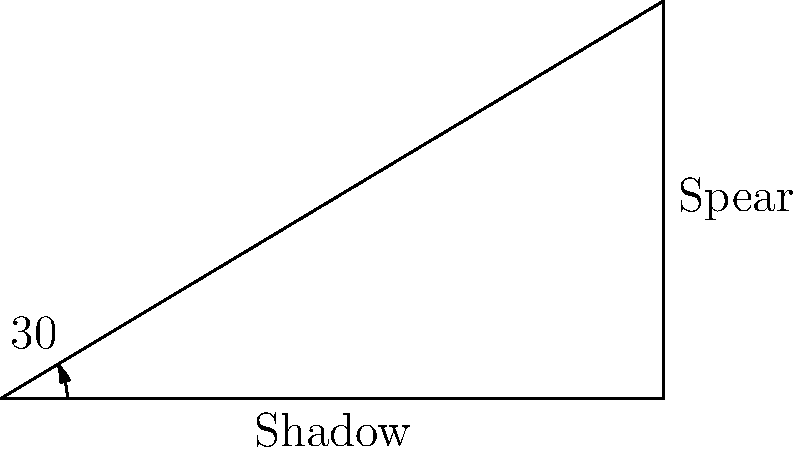An archaeologist discovers an ancient spear casting a shadow on level ground. The shadow is 5 meters long, and the angle of elevation of the sun is 30°. Using trigonometry, calculate the length of the spear to the nearest centimeter. Let's approach this step-by-step:

1) We can represent this scenario as a right-angled triangle, where:
   - The shadow forms the base of the triangle
   - The spear forms the hypotenuse
   - The angle between the shadow and the line from the tip of the spear to the end of the shadow is 30°

2) We know that in a right-angled triangle:
   $\tan(\theta) = \frac{\text{opposite}}{\text{adjacent}}$

3) In this case:
   $\tan(30°) = \frac{\text{spear height}}{\text{shadow length}}$

4) We know the shadow length is 5 meters, so:
   $\tan(30°) = \frac{\text{spear height}}{5}$

5) Rearranging this equation:
   $\text{spear height} = 5 \times \tan(30°)$

6) We know that $\tan(30°) = \frac{1}{\sqrt{3}}$, so:
   $\text{spear height} = 5 \times \frac{1}{\sqrt{3}} \approx 2.887$ meters

7) Now we have a right-angled triangle where we know the base (5m) and the height (2.887m).
   We can find the hypotenuse (spear length) using the Pythagorean theorem:

   $\text{spear length}^2 = 5^2 + 2.887^2$

8) Solving this:
   $\text{spear length} = \sqrt{25 + 8.334} = \sqrt{33.334} \approx 5.774$ meters

9) Rounding to the nearest centimeter:
   $\text{spear length} \approx 5.77$ meters
Answer: 5.77 meters 